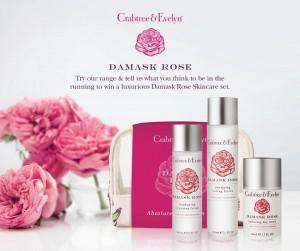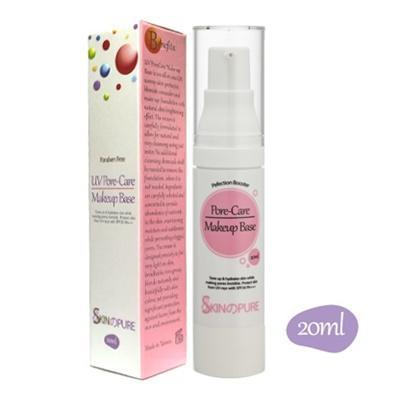The first image is the image on the left, the second image is the image on the right. Evaluate the accuracy of this statement regarding the images: "There is at least one bottle with no box or bag.". Is it true? Answer yes or no. No. 